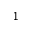Convert formula to latex. <formula><loc_0><loc_0><loc_500><loc_500>1</formula> 